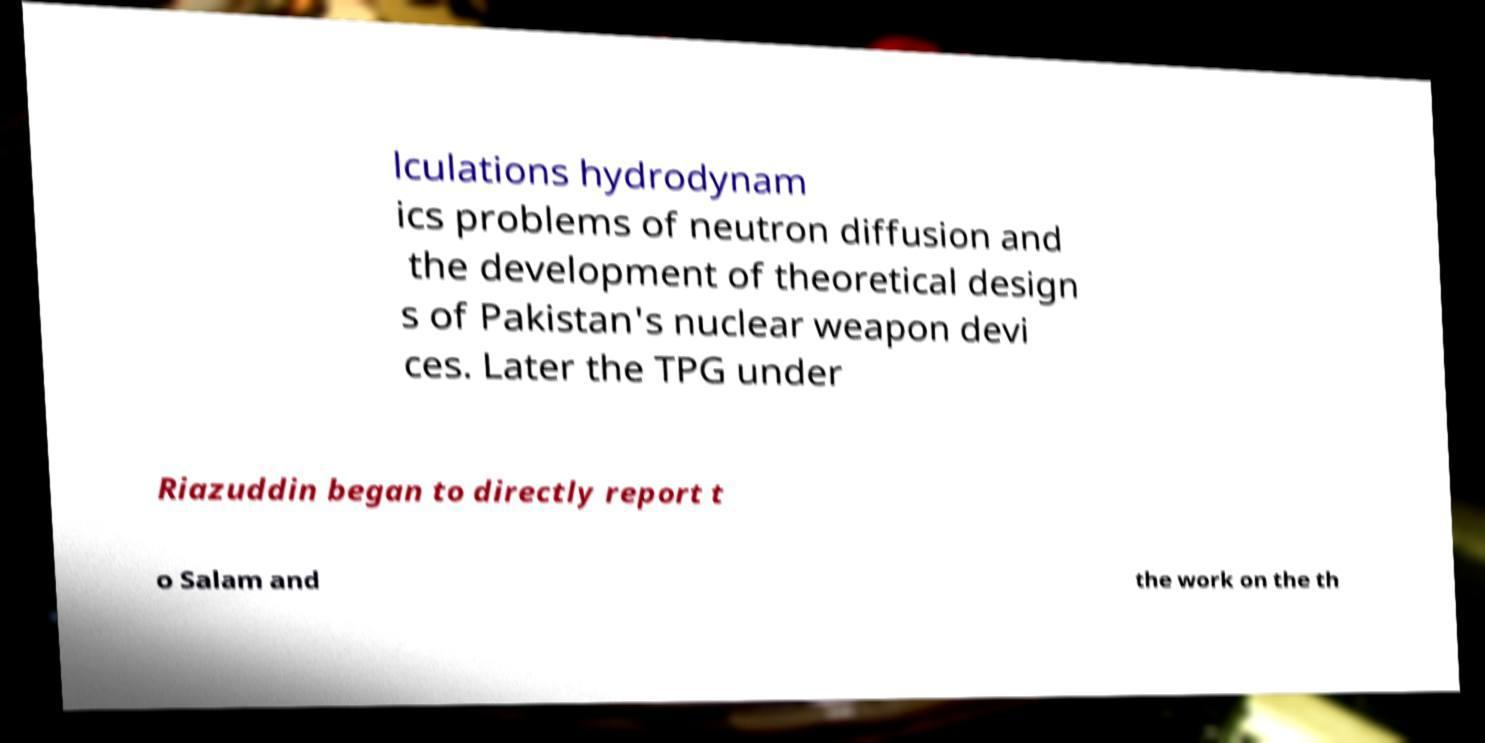For documentation purposes, I need the text within this image transcribed. Could you provide that? lculations hydrodynam ics problems of neutron diffusion and the development of theoretical design s of Pakistan's nuclear weapon devi ces. Later the TPG under Riazuddin began to directly report t o Salam and the work on the th 